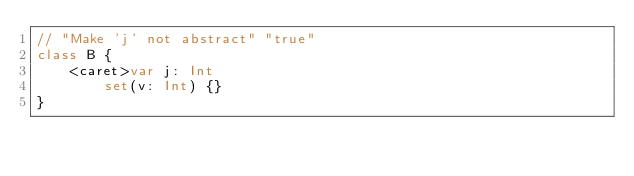<code> <loc_0><loc_0><loc_500><loc_500><_Kotlin_>// "Make 'j' not abstract" "true"
class B {
    <caret>var j: Int
        set(v: Int) {}
}
</code> 